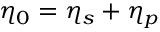<formula> <loc_0><loc_0><loc_500><loc_500>\eta _ { 0 } = \eta _ { s } + \eta _ { p }</formula> 